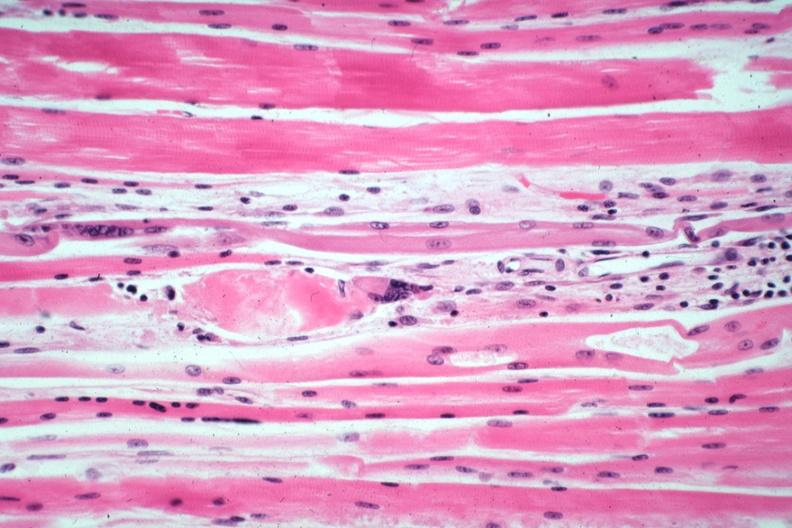what is present?
Answer the question using a single word or phrase. Muscle 